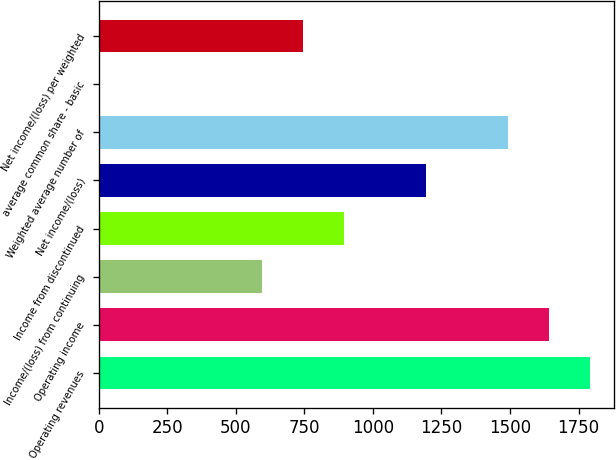Convert chart. <chart><loc_0><loc_0><loc_500><loc_500><bar_chart><fcel>Operating revenues<fcel>Operating income<fcel>Income/(loss) from continuing<fcel>Income from discontinued<fcel>Net income/(loss)<fcel>Weighted average number of<fcel>average common share - basic<fcel>Net income/(loss) per weighted<nl><fcel>1790.42<fcel>1641.22<fcel>596.82<fcel>895.22<fcel>1193.62<fcel>1492.02<fcel>0.02<fcel>746.02<nl></chart> 